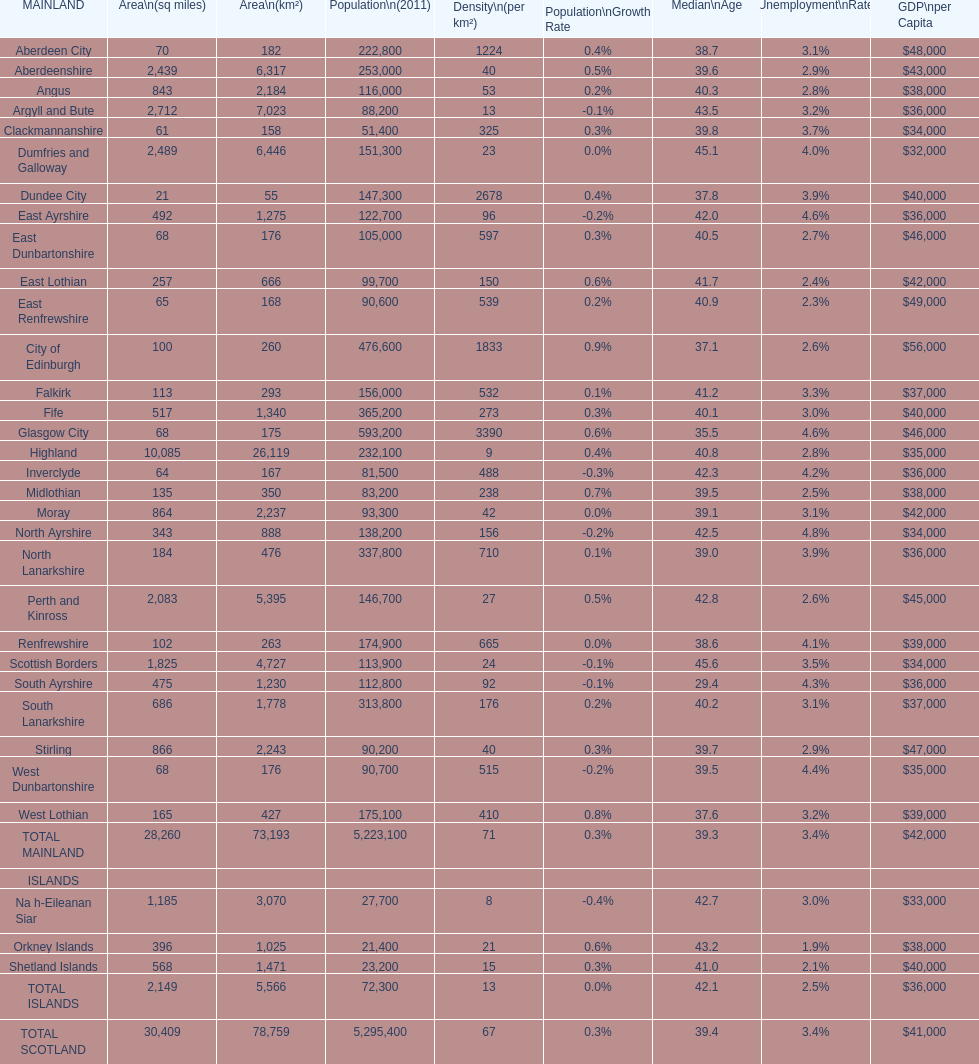I'm looking to parse the entire table for insights. Could you assist me with that? {'header': ['MAINLAND', 'Area\\n(sq miles)', 'Area\\n(km²)', 'Population\\n(2011)', 'Density\\n(per km²)', 'Population\\nGrowth Rate', 'Median\\nAge', 'Unemployment\\nRate', 'GDP\\nper Capita'], 'rows': [['Aberdeen City', '70', '182', '222,800', '1224', '0.4%', '38.7', '3.1%', '$48,000'], ['Aberdeenshire', '2,439', '6,317', '253,000', '40', '0.5%', '39.6', '2.9%', '$43,000'], ['Angus', '843', '2,184', '116,000', '53', '0.2%', '40.3', '2.8%', '$38,000'], ['Argyll and Bute', '2,712', '7,023', '88,200', '13', '-0.1%', '43.5', '3.2%', '$36,000'], ['Clackmannanshire', '61', '158', '51,400', '325', '0.3%', '39.8', '3.7%', '$34,000'], ['Dumfries and Galloway', '2,489', '6,446', '151,300', '23', '0.0%', '45.1', '4.0%', '$32,000'], ['Dundee City', '21', '55', '147,300', '2678', '0.4%', '37.8', '3.9%', '$40,000'], ['East Ayrshire', '492', '1,275', '122,700', '96', '-0.2%', '42.0', '4.6%', '$36,000'], ['East Dunbartonshire', '68', '176', '105,000', '597', '0.3%', '40.5', '2.7%', '$46,000'], ['East Lothian', '257', '666', '99,700', '150', '0.6%', '41.7', '2.4%', '$42,000'], ['East Renfrewshire', '65', '168', '90,600', '539', '0.2%', '40.9', '2.3%', '$49,000'], ['City of Edinburgh', '100', '260', '476,600', '1833', '0.9%', '37.1', '2.6%', '$56,000'], ['Falkirk', '113', '293', '156,000', '532', '0.1%', '41.2', '3.3%', '$37,000'], ['Fife', '517', '1,340', '365,200', '273', '0.3%', '40.1', '3.0%', '$40,000'], ['Glasgow City', '68', '175', '593,200', '3390', '0.6%', '35.5', '4.6%', '$46,000'], ['Highland', '10,085', '26,119', '232,100', '9', '0.4%', '40.8', '2.8%', '$35,000'], ['Inverclyde', '64', '167', '81,500', '488', '-0.3%', '42.3', '4.2%', '$36,000'], ['Midlothian', '135', '350', '83,200', '238', '0.7%', '39.5', '2.5%', '$38,000'], ['Moray', '864', '2,237', '93,300', '42', '0.0%', '39.1', '3.1%', '$42,000'], ['North Ayrshire', '343', '888', '138,200', '156', '-0.2%', '42.5', '4.8%', '$34,000'], ['North Lanarkshire', '184', '476', '337,800', '710', '0.1%', '39.0', '3.9%', '$36,000'], ['Perth and Kinross', '2,083', '5,395', '146,700', '27', '0.5%', '42.8', '2.6%', '$45,000'], ['Renfrewshire', '102', '263', '174,900', '665', '0.0%', '38.6', '4.1%', '$39,000'], ['Scottish Borders', '1,825', '4,727', '113,900', '24', '-0.1%', '45.6', '3.5%', '$34,000'], ['South Ayrshire', '475', '1,230', '112,800', '92', '-0.1%', '29.4', '4.3%', '$36,000'], ['South Lanarkshire', '686', '1,778', '313,800', '176', '0.2%', '40.2', '3.1%', '$37,000'], ['Stirling', '866', '2,243', '90,200', '40', '0.3%', '39.7', '2.9%', '$47,000'], ['West Dunbartonshire', '68', '176', '90,700', '515', '-0.2%', '39.5', '4.4%', '$35,000'], ['West Lothian', '165', '427', '175,100', '410', '0.8%', '37.6', '3.2%', '$39,000'], ['TOTAL MAINLAND', '28,260', '73,193', '5,223,100', '71', '0.3%', '39.3', '3.4%', '$42,000'], ['ISLANDS', '', '', '', '', '', '', '', ''], ['Na h-Eileanan Siar', '1,185', '3,070', '27,700', '8', '-0.4%', '42.7', '3.0%', '$33,000'], ['Orkney Islands', '396', '1,025', '21,400', '21', '0.6%', '43.2', '1.9%', '$38,000'], ['Shetland Islands', '568', '1,471', '23,200', '15', '0.3%', '41.0', '2.1%', '$40,000'], ['TOTAL ISLANDS', '2,149', '5,566', '72,300', '13', '0.0%', '42.1', '2.5%', '$36,000'], ['TOTAL SCOTLAND', '30,409', '78,759', '5,295,400', '67', '0.3%', '39.4', '3.4%', '$41,000']]} If you were to order the places from the least to greatest size, which one would appear first on the list? Dundee City. 